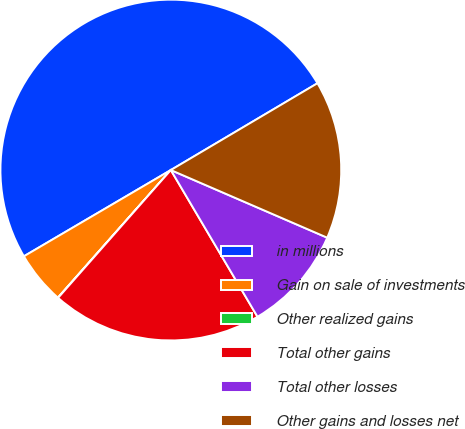Convert chart to OTSL. <chart><loc_0><loc_0><loc_500><loc_500><pie_chart><fcel>in millions<fcel>Gain on sale of investments<fcel>Other realized gains<fcel>Total other gains<fcel>Total other losses<fcel>Other gains and losses net<nl><fcel>49.93%<fcel>5.02%<fcel>0.03%<fcel>19.99%<fcel>10.01%<fcel>15.0%<nl></chart> 